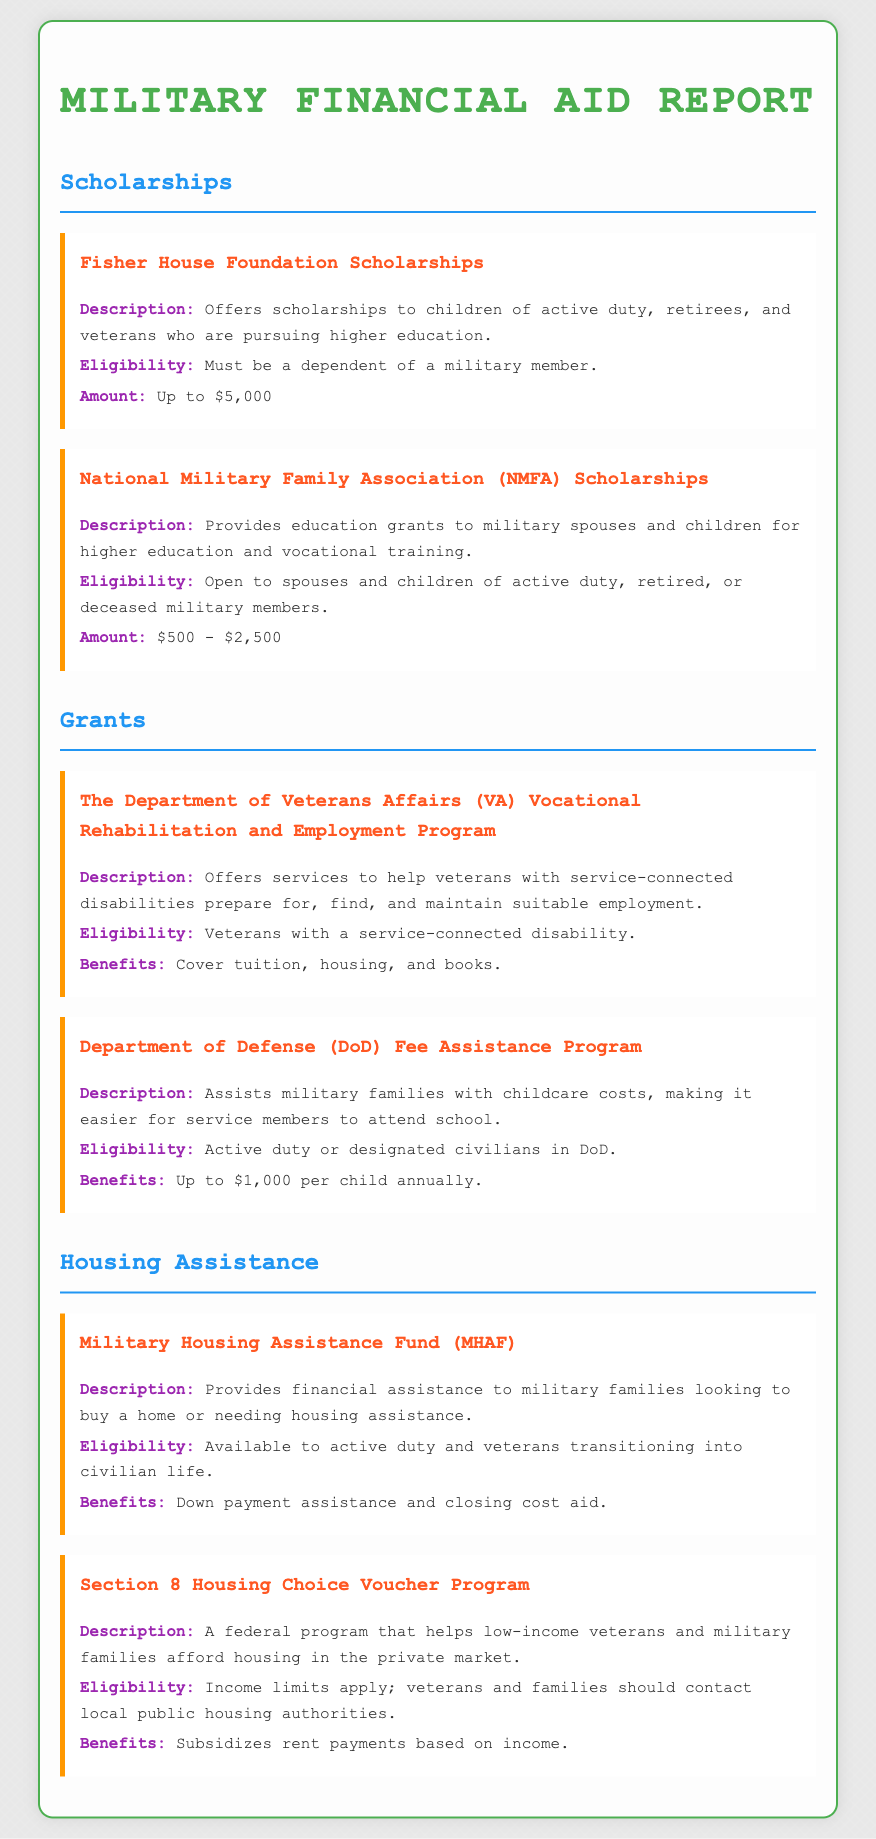What is the maximum amount for Fisher House Foundation Scholarships? The maximum amount is stated explicitly in the document as $5,000.
Answer: $5,000 Who is eligible for the National Military Family Association Scholarships? The eligibility criteria mention that it is open to spouses and children of active duty, retired, or deceased military members.
Answer: Spouses and children of military members What does the VA Vocational Rehabilitation and Employment Program cover? The document specifies that it covers tuition, housing, and books for veterans with service-connected disabilities.
Answer: Tuition, housing, and books How much can families receive from the DoD Fee Assistance Program per child annually? The document states that the benefit is up to $1,000 per child annually.
Answer: Up to $1,000 What is the primary purpose of the Military Housing Assistance Fund? It is aimed at providing financial assistance to military families looking to buy a home or needing housing assistance.
Answer: Financial assistance for housing How does the Section 8 Housing Choice Voucher Program assist military families? The program subsidizes rent payments based on income, making housing more affordable for low-income families.
Answer: Subsidizes rent payments What type of aid does the National Military Family Association provide? The aid provided includes education grants for higher education and vocational training.
Answer: Education grants What must applicants have to be eligible for the Fisher House Foundation Scholarships? Applicants must be dependents of military members to be eligible for the scholarships.
Answer: Dependent of a military member 